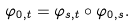<formula> <loc_0><loc_0><loc_500><loc_500>\varphi _ { 0 , t } = \varphi _ { s , t } \circ \varphi _ { 0 , s } .</formula> 